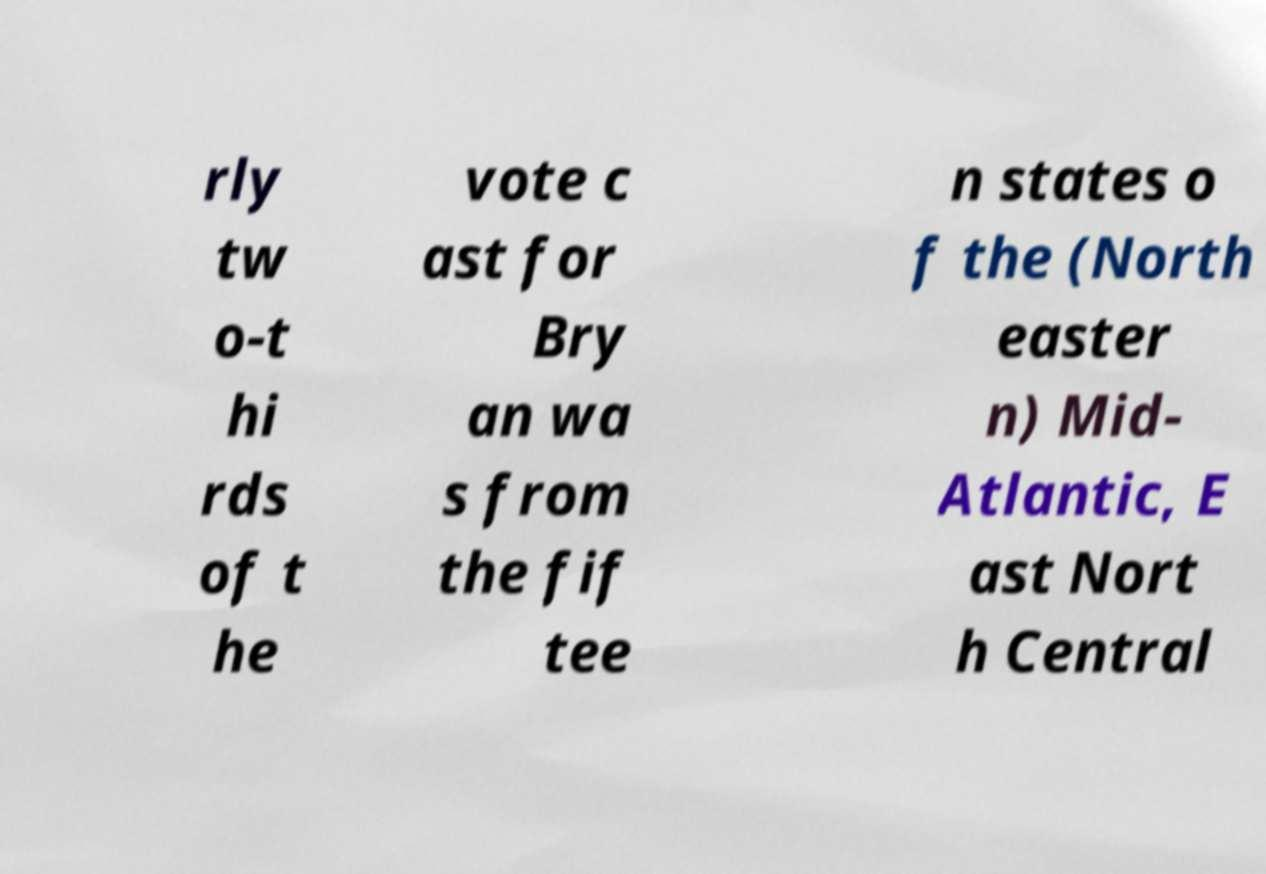What messages or text are displayed in this image? I need them in a readable, typed format. rly tw o-t hi rds of t he vote c ast for Bry an wa s from the fif tee n states o f the (North easter n) Mid- Atlantic, E ast Nort h Central 